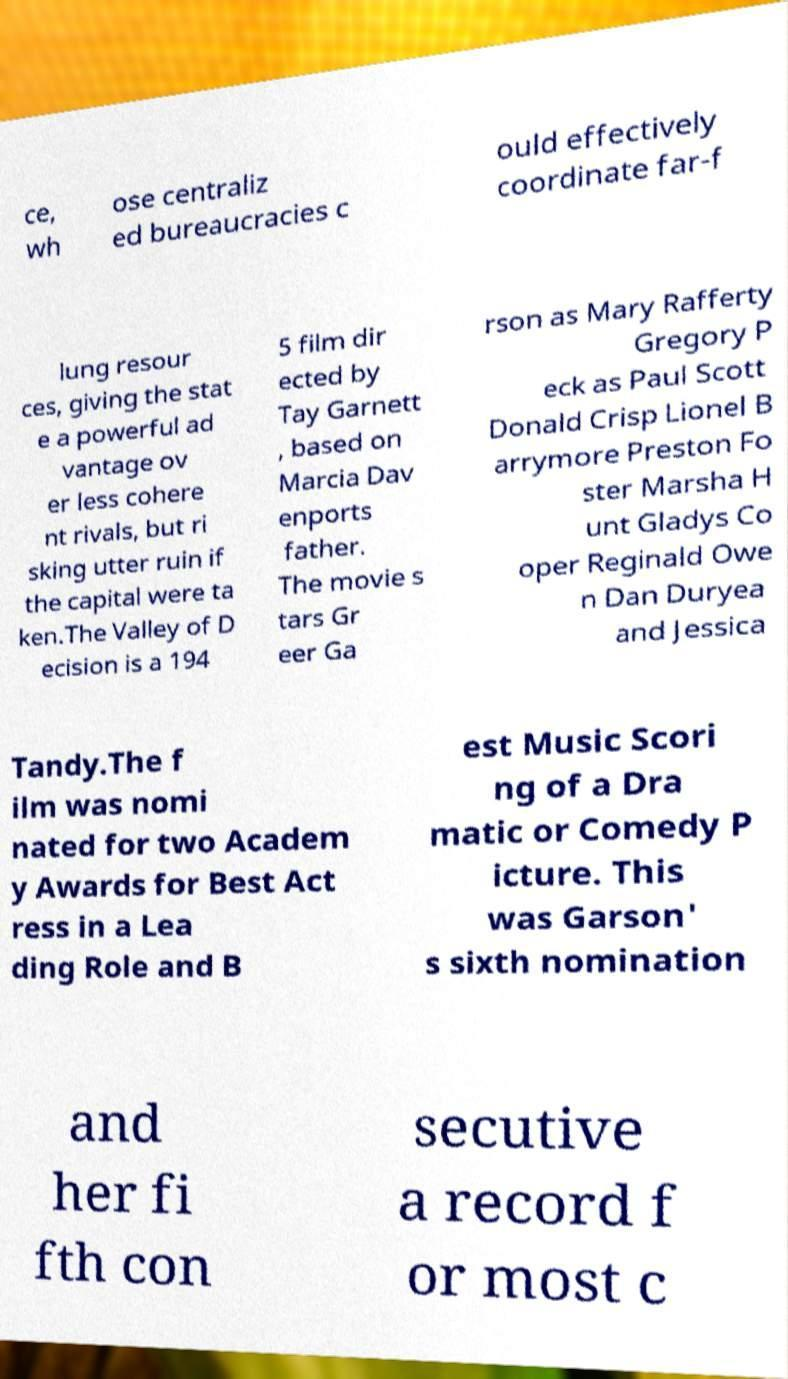Please read and relay the text visible in this image. What does it say? ce, wh ose centraliz ed bureaucracies c ould effectively coordinate far-f lung resour ces, giving the stat e a powerful ad vantage ov er less cohere nt rivals, but ri sking utter ruin if the capital were ta ken.The Valley of D ecision is a 194 5 film dir ected by Tay Garnett , based on Marcia Dav enports father. The movie s tars Gr eer Ga rson as Mary Rafferty Gregory P eck as Paul Scott Donald Crisp Lionel B arrymore Preston Fo ster Marsha H unt Gladys Co oper Reginald Owe n Dan Duryea and Jessica Tandy.The f ilm was nomi nated for two Academ y Awards for Best Act ress in a Lea ding Role and B est Music Scori ng of a Dra matic or Comedy P icture. This was Garson' s sixth nomination and her fi fth con secutive a record f or most c 